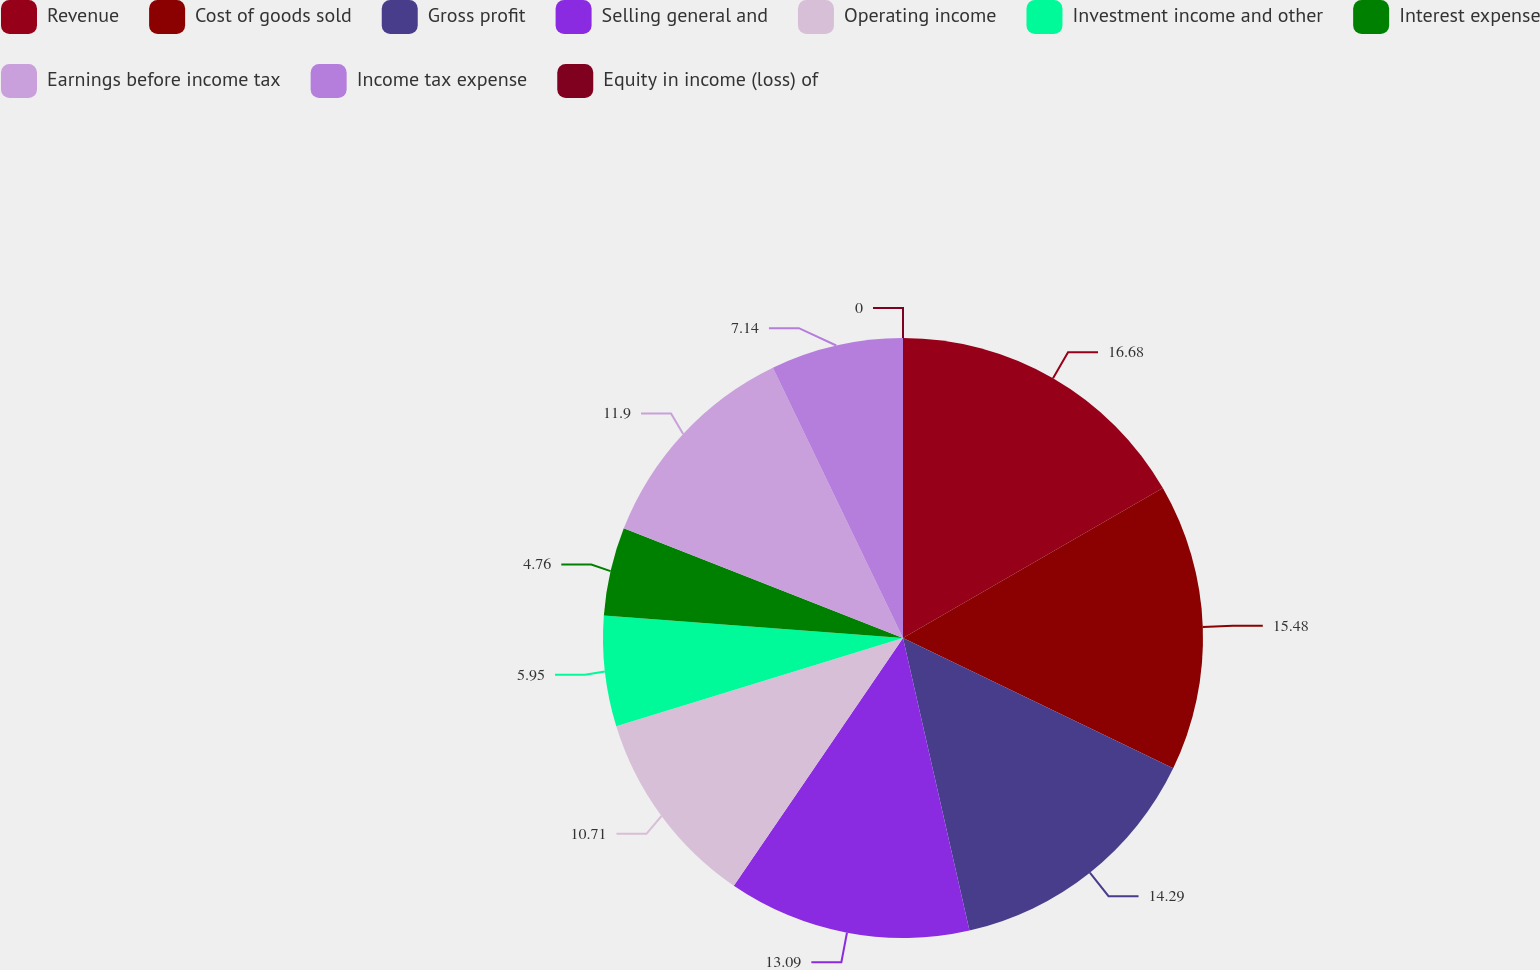<chart> <loc_0><loc_0><loc_500><loc_500><pie_chart><fcel>Revenue<fcel>Cost of goods sold<fcel>Gross profit<fcel>Selling general and<fcel>Operating income<fcel>Investment income and other<fcel>Interest expense<fcel>Earnings before income tax<fcel>Income tax expense<fcel>Equity in income (loss) of<nl><fcel>16.67%<fcel>15.48%<fcel>14.29%<fcel>13.09%<fcel>10.71%<fcel>5.95%<fcel>4.76%<fcel>11.9%<fcel>7.14%<fcel>0.0%<nl></chart> 